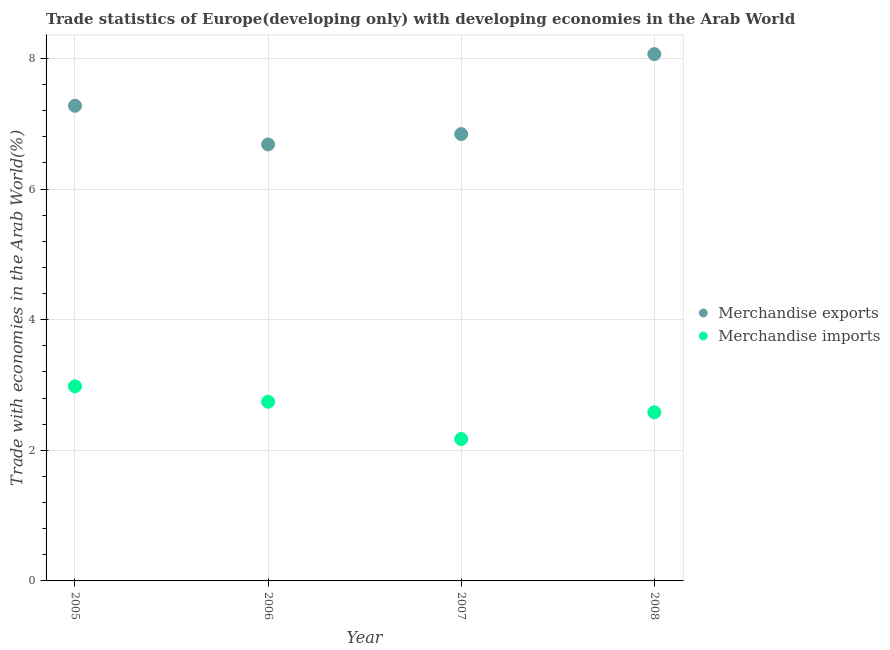How many different coloured dotlines are there?
Provide a succinct answer. 2. What is the merchandise imports in 2006?
Offer a very short reply. 2.74. Across all years, what is the maximum merchandise exports?
Your response must be concise. 8.07. Across all years, what is the minimum merchandise exports?
Your answer should be compact. 6.68. What is the total merchandise exports in the graph?
Give a very brief answer. 28.87. What is the difference between the merchandise imports in 2006 and that in 2008?
Your answer should be compact. 0.16. What is the difference between the merchandise exports in 2006 and the merchandise imports in 2005?
Give a very brief answer. 3.7. What is the average merchandise exports per year?
Provide a short and direct response. 7.22. In the year 2006, what is the difference between the merchandise exports and merchandise imports?
Your answer should be very brief. 3.94. In how many years, is the merchandise imports greater than 6.4 %?
Provide a short and direct response. 0. What is the ratio of the merchandise imports in 2006 to that in 2007?
Your response must be concise. 1.26. Is the merchandise imports in 2007 less than that in 2008?
Your answer should be very brief. Yes. What is the difference between the highest and the second highest merchandise imports?
Provide a succinct answer. 0.24. What is the difference between the highest and the lowest merchandise imports?
Your answer should be compact. 0.81. How many years are there in the graph?
Offer a very short reply. 4. Does the graph contain any zero values?
Offer a terse response. No. Does the graph contain grids?
Ensure brevity in your answer.  Yes. How are the legend labels stacked?
Give a very brief answer. Vertical. What is the title of the graph?
Offer a terse response. Trade statistics of Europe(developing only) with developing economies in the Arab World. What is the label or title of the X-axis?
Offer a very short reply. Year. What is the label or title of the Y-axis?
Offer a terse response. Trade with economies in the Arab World(%). What is the Trade with economies in the Arab World(%) in Merchandise exports in 2005?
Make the answer very short. 7.28. What is the Trade with economies in the Arab World(%) in Merchandise imports in 2005?
Your answer should be compact. 2.98. What is the Trade with economies in the Arab World(%) of Merchandise exports in 2006?
Provide a short and direct response. 6.68. What is the Trade with economies in the Arab World(%) of Merchandise imports in 2006?
Ensure brevity in your answer.  2.74. What is the Trade with economies in the Arab World(%) of Merchandise exports in 2007?
Provide a succinct answer. 6.84. What is the Trade with economies in the Arab World(%) of Merchandise imports in 2007?
Offer a terse response. 2.17. What is the Trade with economies in the Arab World(%) in Merchandise exports in 2008?
Offer a very short reply. 8.07. What is the Trade with economies in the Arab World(%) of Merchandise imports in 2008?
Provide a succinct answer. 2.58. Across all years, what is the maximum Trade with economies in the Arab World(%) in Merchandise exports?
Ensure brevity in your answer.  8.07. Across all years, what is the maximum Trade with economies in the Arab World(%) of Merchandise imports?
Make the answer very short. 2.98. Across all years, what is the minimum Trade with economies in the Arab World(%) of Merchandise exports?
Provide a short and direct response. 6.68. Across all years, what is the minimum Trade with economies in the Arab World(%) of Merchandise imports?
Provide a succinct answer. 2.17. What is the total Trade with economies in the Arab World(%) of Merchandise exports in the graph?
Keep it short and to the point. 28.86. What is the total Trade with economies in the Arab World(%) in Merchandise imports in the graph?
Ensure brevity in your answer.  10.48. What is the difference between the Trade with economies in the Arab World(%) of Merchandise exports in 2005 and that in 2006?
Your answer should be compact. 0.59. What is the difference between the Trade with economies in the Arab World(%) of Merchandise imports in 2005 and that in 2006?
Your answer should be very brief. 0.24. What is the difference between the Trade with economies in the Arab World(%) of Merchandise exports in 2005 and that in 2007?
Keep it short and to the point. 0.43. What is the difference between the Trade with economies in the Arab World(%) of Merchandise imports in 2005 and that in 2007?
Keep it short and to the point. 0.81. What is the difference between the Trade with economies in the Arab World(%) of Merchandise exports in 2005 and that in 2008?
Give a very brief answer. -0.79. What is the difference between the Trade with economies in the Arab World(%) in Merchandise imports in 2005 and that in 2008?
Make the answer very short. 0.4. What is the difference between the Trade with economies in the Arab World(%) in Merchandise exports in 2006 and that in 2007?
Offer a terse response. -0.16. What is the difference between the Trade with economies in the Arab World(%) of Merchandise imports in 2006 and that in 2007?
Offer a very short reply. 0.57. What is the difference between the Trade with economies in the Arab World(%) of Merchandise exports in 2006 and that in 2008?
Your response must be concise. -1.38. What is the difference between the Trade with economies in the Arab World(%) in Merchandise imports in 2006 and that in 2008?
Make the answer very short. 0.16. What is the difference between the Trade with economies in the Arab World(%) of Merchandise exports in 2007 and that in 2008?
Your answer should be compact. -1.22. What is the difference between the Trade with economies in the Arab World(%) in Merchandise imports in 2007 and that in 2008?
Your answer should be very brief. -0.41. What is the difference between the Trade with economies in the Arab World(%) in Merchandise exports in 2005 and the Trade with economies in the Arab World(%) in Merchandise imports in 2006?
Ensure brevity in your answer.  4.53. What is the difference between the Trade with economies in the Arab World(%) of Merchandise exports in 2005 and the Trade with economies in the Arab World(%) of Merchandise imports in 2007?
Offer a very short reply. 5.1. What is the difference between the Trade with economies in the Arab World(%) of Merchandise exports in 2005 and the Trade with economies in the Arab World(%) of Merchandise imports in 2008?
Provide a short and direct response. 4.69. What is the difference between the Trade with economies in the Arab World(%) in Merchandise exports in 2006 and the Trade with economies in the Arab World(%) in Merchandise imports in 2007?
Keep it short and to the point. 4.51. What is the difference between the Trade with economies in the Arab World(%) of Merchandise exports in 2006 and the Trade with economies in the Arab World(%) of Merchandise imports in 2008?
Offer a very short reply. 4.1. What is the difference between the Trade with economies in the Arab World(%) of Merchandise exports in 2007 and the Trade with economies in the Arab World(%) of Merchandise imports in 2008?
Offer a very short reply. 4.26. What is the average Trade with economies in the Arab World(%) in Merchandise exports per year?
Give a very brief answer. 7.22. What is the average Trade with economies in the Arab World(%) in Merchandise imports per year?
Provide a short and direct response. 2.62. In the year 2005, what is the difference between the Trade with economies in the Arab World(%) in Merchandise exports and Trade with economies in the Arab World(%) in Merchandise imports?
Keep it short and to the point. 4.3. In the year 2006, what is the difference between the Trade with economies in the Arab World(%) in Merchandise exports and Trade with economies in the Arab World(%) in Merchandise imports?
Provide a short and direct response. 3.94. In the year 2007, what is the difference between the Trade with economies in the Arab World(%) in Merchandise exports and Trade with economies in the Arab World(%) in Merchandise imports?
Keep it short and to the point. 4.67. In the year 2008, what is the difference between the Trade with economies in the Arab World(%) in Merchandise exports and Trade with economies in the Arab World(%) in Merchandise imports?
Offer a very short reply. 5.48. What is the ratio of the Trade with economies in the Arab World(%) of Merchandise exports in 2005 to that in 2006?
Offer a very short reply. 1.09. What is the ratio of the Trade with economies in the Arab World(%) of Merchandise imports in 2005 to that in 2006?
Provide a short and direct response. 1.09. What is the ratio of the Trade with economies in the Arab World(%) of Merchandise exports in 2005 to that in 2007?
Offer a terse response. 1.06. What is the ratio of the Trade with economies in the Arab World(%) in Merchandise imports in 2005 to that in 2007?
Make the answer very short. 1.37. What is the ratio of the Trade with economies in the Arab World(%) of Merchandise exports in 2005 to that in 2008?
Keep it short and to the point. 0.9. What is the ratio of the Trade with economies in the Arab World(%) in Merchandise imports in 2005 to that in 2008?
Keep it short and to the point. 1.15. What is the ratio of the Trade with economies in the Arab World(%) of Merchandise exports in 2006 to that in 2007?
Ensure brevity in your answer.  0.98. What is the ratio of the Trade with economies in the Arab World(%) in Merchandise imports in 2006 to that in 2007?
Ensure brevity in your answer.  1.26. What is the ratio of the Trade with economies in the Arab World(%) in Merchandise exports in 2006 to that in 2008?
Your answer should be compact. 0.83. What is the ratio of the Trade with economies in the Arab World(%) in Merchandise imports in 2006 to that in 2008?
Your answer should be very brief. 1.06. What is the ratio of the Trade with economies in the Arab World(%) of Merchandise exports in 2007 to that in 2008?
Your answer should be compact. 0.85. What is the ratio of the Trade with economies in the Arab World(%) in Merchandise imports in 2007 to that in 2008?
Give a very brief answer. 0.84. What is the difference between the highest and the second highest Trade with economies in the Arab World(%) of Merchandise exports?
Your response must be concise. 0.79. What is the difference between the highest and the second highest Trade with economies in the Arab World(%) of Merchandise imports?
Provide a short and direct response. 0.24. What is the difference between the highest and the lowest Trade with economies in the Arab World(%) of Merchandise exports?
Offer a terse response. 1.38. What is the difference between the highest and the lowest Trade with economies in the Arab World(%) of Merchandise imports?
Your answer should be compact. 0.81. 